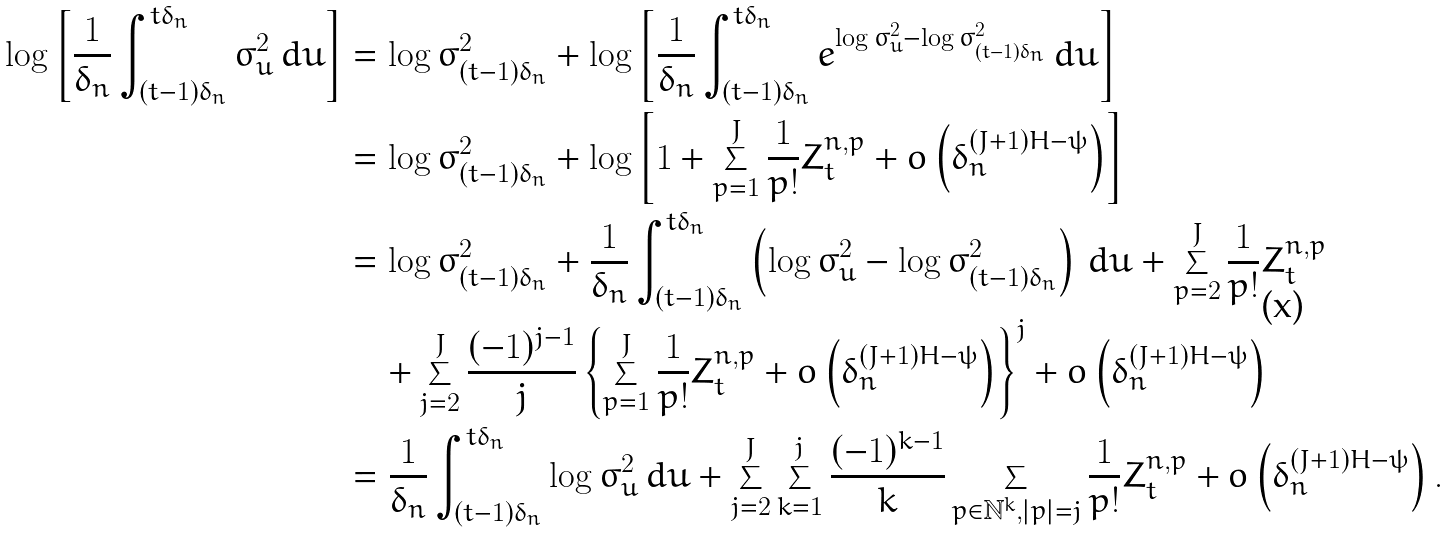<formula> <loc_0><loc_0><loc_500><loc_500>\log \left [ \frac { 1 } { \delta _ { n } } \int _ { ( t - 1 ) \delta _ { n } } ^ { t \delta _ { n } } \sigma ^ { 2 } _ { u } \, d u \right ] & = \log \sigma ^ { 2 } _ { ( t - 1 ) \delta _ { n } } + \log \left [ \frac { 1 } { \delta _ { n } } \int _ { ( t - 1 ) \delta _ { n } } ^ { t \delta _ { n } } e ^ { \log \sigma ^ { 2 } _ { u } - \log \sigma ^ { 2 } _ { ( t - 1 ) \delta _ { n } } } \, d u \right ] \\ & = \log \sigma ^ { 2 } _ { ( t - 1 ) \delta _ { n } } + \log \left [ 1 + \sum _ { p = 1 } ^ { J } \frac { 1 } { p ! } Z _ { t } ^ { n , p } + o \left ( \delta _ { n } ^ { ( J + 1 ) H - \psi } \right ) \right ] \\ & = \log \sigma ^ { 2 } _ { ( t - 1 ) \delta _ { n } } + \frac { 1 } { \delta _ { n } } \int _ { ( t - 1 ) \delta _ { n } } ^ { t \delta _ { n } } \left ( \log \sigma ^ { 2 } _ { u } - \log \sigma ^ { 2 } _ { ( t - 1 ) \delta _ { n } } \right ) \, d u + \sum _ { p = 2 } ^ { J } \frac { 1 } { p ! } Z _ { t } ^ { n , p } \\ & \quad + \sum _ { j = 2 } ^ { J } \frac { ( - 1 ) ^ { j - 1 } } { j } \left \{ \sum _ { p = 1 } ^ { J } \frac { 1 } { p ! } Z _ { t } ^ { n , p } + o \left ( \delta _ { n } ^ { ( J + 1 ) H - \psi } \right ) \right \} ^ { j } + o \left ( \delta _ { n } ^ { ( J + 1 ) H - \psi } \right ) \\ & = \frac { 1 } { \delta _ { n } } \int _ { ( t - 1 ) \delta _ { n } } ^ { t \delta _ { n } } \log \sigma ^ { 2 } _ { u } \, d u + \sum _ { j = 2 } ^ { J } \sum _ { k = 1 } ^ { j } \frac { ( - 1 ) ^ { k - 1 } } { k } \sum _ { p \in \mathbb { N } ^ { k } , | p | = j } \frac { 1 } { p ! } Z _ { t } ^ { n , p } + o \left ( \delta _ { n } ^ { ( J + 1 ) H - \psi } \right ) .</formula> 